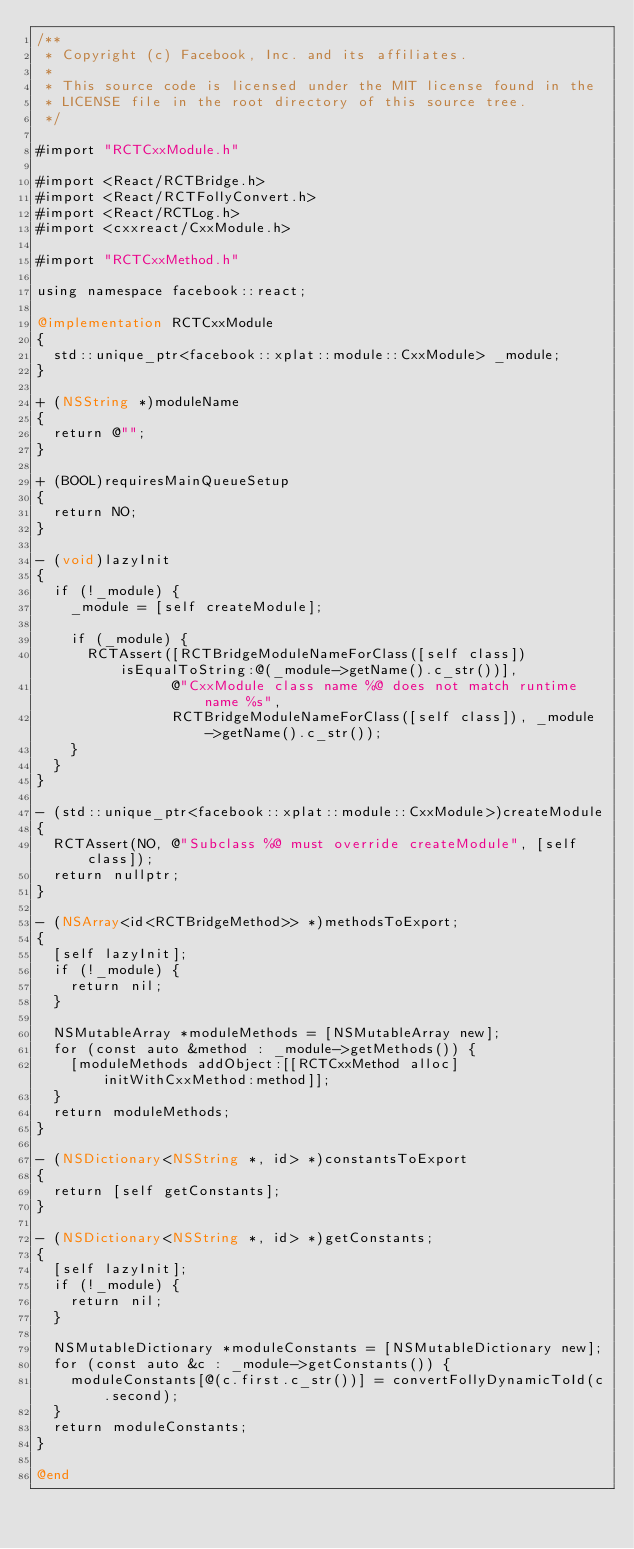<code> <loc_0><loc_0><loc_500><loc_500><_ObjectiveC_>/**
 * Copyright (c) Facebook, Inc. and its affiliates.
 *
 * This source code is licensed under the MIT license found in the
 * LICENSE file in the root directory of this source tree.
 */

#import "RCTCxxModule.h"

#import <React/RCTBridge.h>
#import <React/RCTFollyConvert.h>
#import <React/RCTLog.h>
#import <cxxreact/CxxModule.h>

#import "RCTCxxMethod.h"

using namespace facebook::react;

@implementation RCTCxxModule
{
  std::unique_ptr<facebook::xplat::module::CxxModule> _module;
}

+ (NSString *)moduleName
{
  return @"";
}

+ (BOOL)requiresMainQueueSetup
{
  return NO;
}

- (void)lazyInit
{
  if (!_module) {
    _module = [self createModule];

    if (_module) {
      RCTAssert([RCTBridgeModuleNameForClass([self class]) isEqualToString:@(_module->getName().c_str())],
                @"CxxModule class name %@ does not match runtime name %s",
                RCTBridgeModuleNameForClass([self class]), _module->getName().c_str());
    }
  }
}

- (std::unique_ptr<facebook::xplat::module::CxxModule>)createModule
{
  RCTAssert(NO, @"Subclass %@ must override createModule", [self class]);
  return nullptr;
}

- (NSArray<id<RCTBridgeMethod>> *)methodsToExport;
{
  [self lazyInit];
  if (!_module) {
    return nil;
  }

  NSMutableArray *moduleMethods = [NSMutableArray new];
  for (const auto &method : _module->getMethods()) {
    [moduleMethods addObject:[[RCTCxxMethod alloc] initWithCxxMethod:method]];
  }
  return moduleMethods;
}

- (NSDictionary<NSString *, id> *)constantsToExport
{
  return [self getConstants];
}

- (NSDictionary<NSString *, id> *)getConstants;
{
  [self lazyInit];
  if (!_module) {
    return nil;
  }

  NSMutableDictionary *moduleConstants = [NSMutableDictionary new];
  for (const auto &c : _module->getConstants()) {
    moduleConstants[@(c.first.c_str())] = convertFollyDynamicToId(c.second);
  }
  return moduleConstants;
}

@end
</code> 